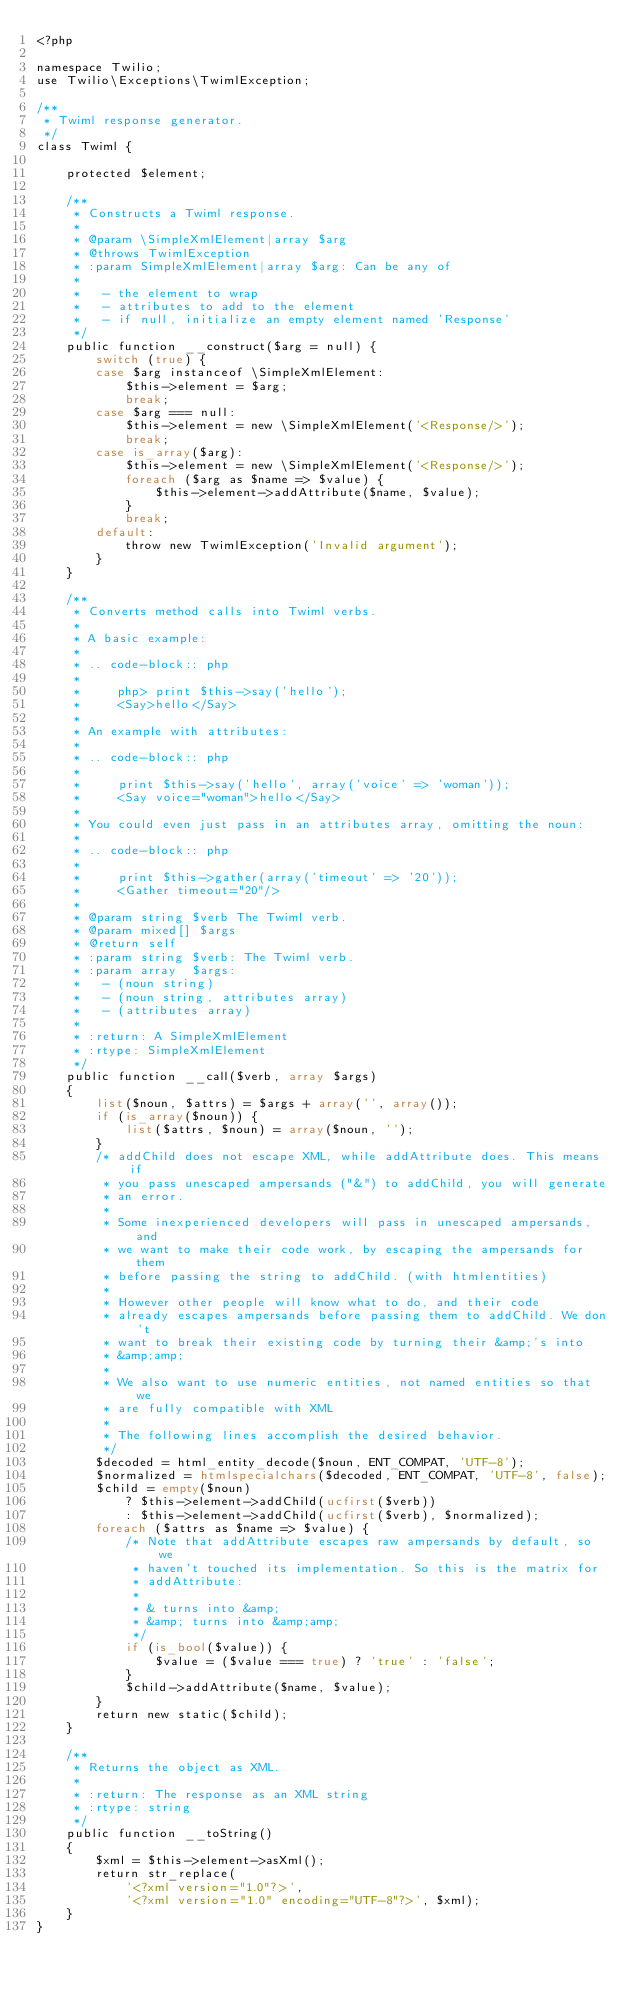Convert code to text. <code><loc_0><loc_0><loc_500><loc_500><_PHP_><?php

namespace Twilio;
use Twilio\Exceptions\TwimlException;

/**
 * Twiml response generator.
 */
class Twiml {

    protected $element;

    /**
     * Constructs a Twiml response.
     *
     * @param \SimpleXmlElement|array $arg
     * @throws TwimlException
     * :param SimpleXmlElement|array $arg: Can be any of
     *
     *   - the element to wrap
     *   - attributes to add to the element
     *   - if null, initialize an empty element named 'Response'
     */
    public function __construct($arg = null) {
        switch (true) {
        case $arg instanceof \SimpleXmlElement:
            $this->element = $arg;
            break;
        case $arg === null:
            $this->element = new \SimpleXmlElement('<Response/>');
            break;
        case is_array($arg):
            $this->element = new \SimpleXmlElement('<Response/>');
            foreach ($arg as $name => $value) {
                $this->element->addAttribute($name, $value);
            }
            break;
        default:
            throw new TwimlException('Invalid argument');
        }
    }

    /**
     * Converts method calls into Twiml verbs.
     *
     * A basic example:
     *
     * .. code-block:: php
     *
     *     php> print $this->say('hello');
     *     <Say>hello</Say>
     *
     * An example with attributes:
     *
     * .. code-block:: php
     *
     *     print $this->say('hello', array('voice' => 'woman'));
     *     <Say voice="woman">hello</Say>
     *
     * You could even just pass in an attributes array, omitting the noun:
     *
     * .. code-block:: php
     *
     *     print $this->gather(array('timeout' => '20'));
     *     <Gather timeout="20"/>
     *
     * @param string $verb The Twiml verb.
     * @param mixed[] $args
     * @return self
     * :param string $verb: The Twiml verb.
     * :param array  $args:
     *   - (noun string)
     *   - (noun string, attributes array)
     *   - (attributes array)
     *
     * :return: A SimpleXmlElement
     * :rtype: SimpleXmlElement
     */
    public function __call($verb, array $args)
    {
        list($noun, $attrs) = $args + array('', array());
        if (is_array($noun)) {
            list($attrs, $noun) = array($noun, '');
        }
        /* addChild does not escape XML, while addAttribute does. This means if
         * you pass unescaped ampersands ("&") to addChild, you will generate
         * an error.
         *
         * Some inexperienced developers will pass in unescaped ampersands, and
         * we want to make their code work, by escaping the ampersands for them
         * before passing the string to addChild. (with htmlentities)
         *
         * However other people will know what to do, and their code
         * already escapes ampersands before passing them to addChild. We don't
         * want to break their existing code by turning their &amp;'s into
         * &amp;amp;
         *
         * We also want to use numeric entities, not named entities so that we
         * are fully compatible with XML
         *
         * The following lines accomplish the desired behavior.
         */
        $decoded = html_entity_decode($noun, ENT_COMPAT, 'UTF-8');
        $normalized = htmlspecialchars($decoded, ENT_COMPAT, 'UTF-8', false);
        $child = empty($noun)
            ? $this->element->addChild(ucfirst($verb))
            : $this->element->addChild(ucfirst($verb), $normalized);
        foreach ($attrs as $name => $value) {
            /* Note that addAttribute escapes raw ampersands by default, so we
             * haven't touched its implementation. So this is the matrix for
             * addAttribute:
             *
             * & turns into &amp;
             * &amp; turns into &amp;amp;
             */
            if (is_bool($value)) {
                $value = ($value === true) ? 'true' : 'false';
            }
            $child->addAttribute($name, $value);
        }
        return new static($child);
    }

    /**
     * Returns the object as XML.
     *
     * :return: The response as an XML string
     * :rtype: string
     */
    public function __toString()
    {
        $xml = $this->element->asXml();
        return str_replace(
            '<?xml version="1.0"?>',
            '<?xml version="1.0" encoding="UTF-8"?>', $xml);
    }
}
</code> 